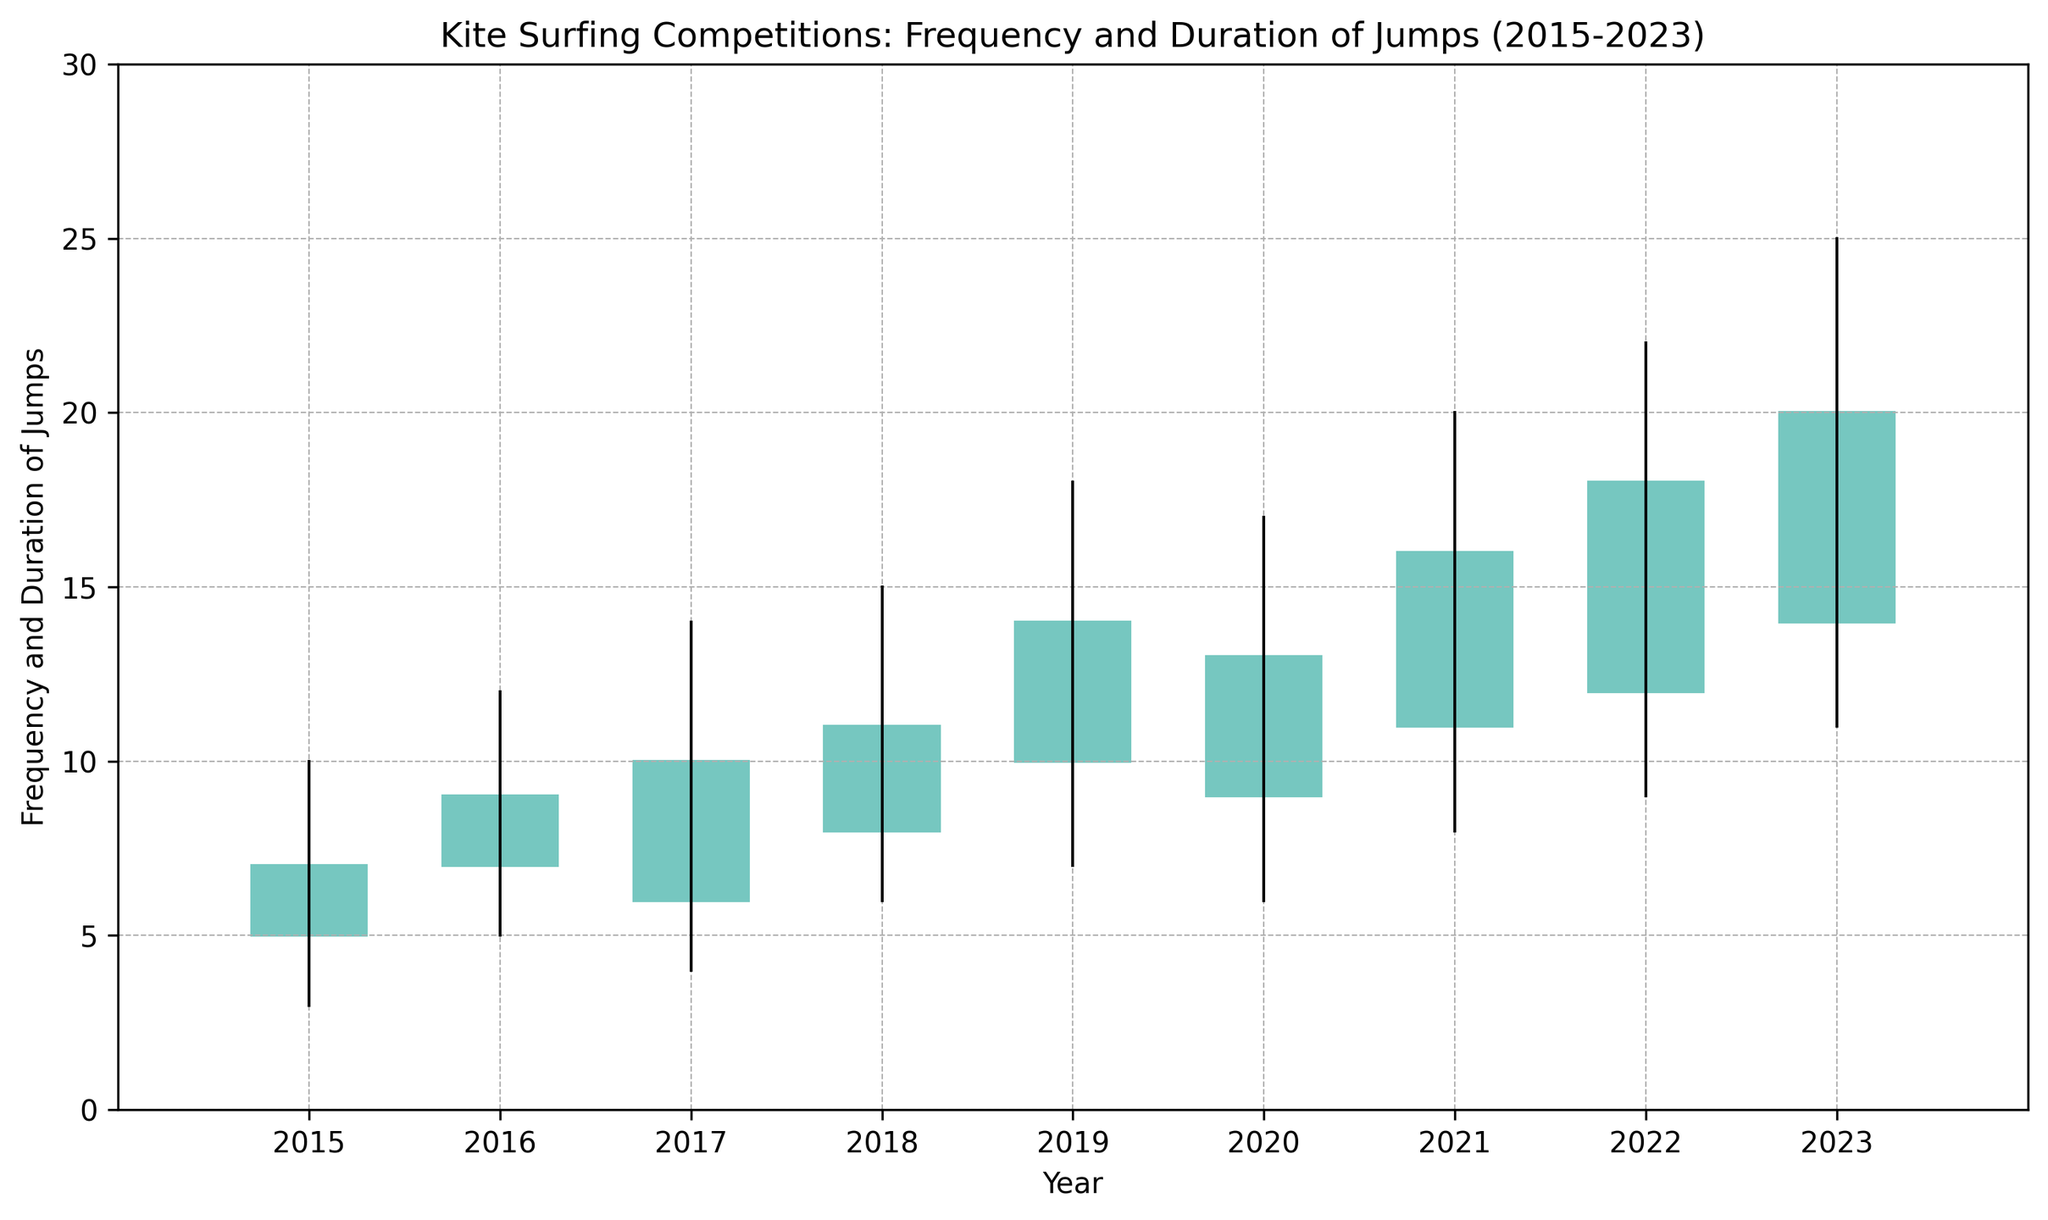What is the highest point reach in the year 2023? Look at the highest value in the candlestick for the year 2023; it is the topmost point of the figure. The highest point for 2023 is 25.
Answer: 25 Which year had the highest increase from open to close values in jumps? Calculate the difference between the Open and Close values for each year. The year with the highest increase is found by checking which year had the greatest difference. The differences are: 2015(2), 2016(2), 2017(4), 2018(3), 2019(4), 2020(4), 2021(5), 2022(6), 2023(6). So, it's 2022 and 2023.
Answer: 2022 and 2023 What is the range of jump frequencies in 2019? Identify the highest and lowest points for the year 2019 which are 18 (High) and 7 (Low). Subtract the Low value from the High value. The range is 18 - 7 = 11.
Answer: 11 Which year had the smallest variation in jump values? Calculate the range by subtracting the Low value from the High value for each year. The smallest range indicates the smallest variation. The ranges are: 2015(7), 2016(7), 2017(10), 2018(9), 2019(11), 2020(11), 2021(12), 2022(13), 2023(14). So, it is 2015 and 2016.
Answer: 2015 and 2016 Between which consecutive years was there the biggest decrease from the Close value of one year to the Open value of the next year? Calculate the difference by subtracting the Open value of the next year from the Close value of the previous year. The decreases are: 2015-2016(0), 2016-2017(-2), 2017-2018(-2), 2018-2019(-1), 2019-2020(-4), 2020-2021(-1), 2021-2022(-1), 2022-2023(-2). The biggest decrease is from 2019 to 2020.
Answer: 2019 to 2020 In which year did the jump duration have the highest low point? Identify the lowest points for each year and find the maximum of these values. The lowest points are: 2015(3), 2016(5), 2017(4), 2018(6), 2019(7), 2020(6), 2021(8), 2022(9), 2023(11). Therefore, 2023 had the highest low point.
Answer: 2023 Between 2015 and 2023, which year had the highest overall jump frequency and duration (Close value)? Check the Close value for each year and find the highest one. The Close values are: 2015(7), 2016(9), 2017(10), 2018(11), 2019(14), 2020(13), 2021(16), 2022(18), 2023(20). The highest Close value is in 2023.
Answer: 2023 How many years had a closing value greater than 10? Count the years where the Close value is more than 10. Close values greater than 10 are in the years: 2018(11), 2019(14), 2020(13), 2021(16), 2022(18), 2023(20). There are 6 such years.
Answer: 6 What was the average high value for the given years? Add up all the High values and divide by the number of years. (10 + 12 + 14 + 15 + 18 + 17 + 20 + 22 + 25) / 9 = 153 / 9 = 17
Answer: 17 How did the frequency and duration of jumps change from 2015 to 2023? Compare the Open, High, Low, and Close values between 2015 and 2023. Open increased from 5 to 14, High increased from 10 to 25, Low increased from 3 to 11, and Close increased from 7 to 20, indicating an overall rise in frequency and duration.
Answer: Increase 